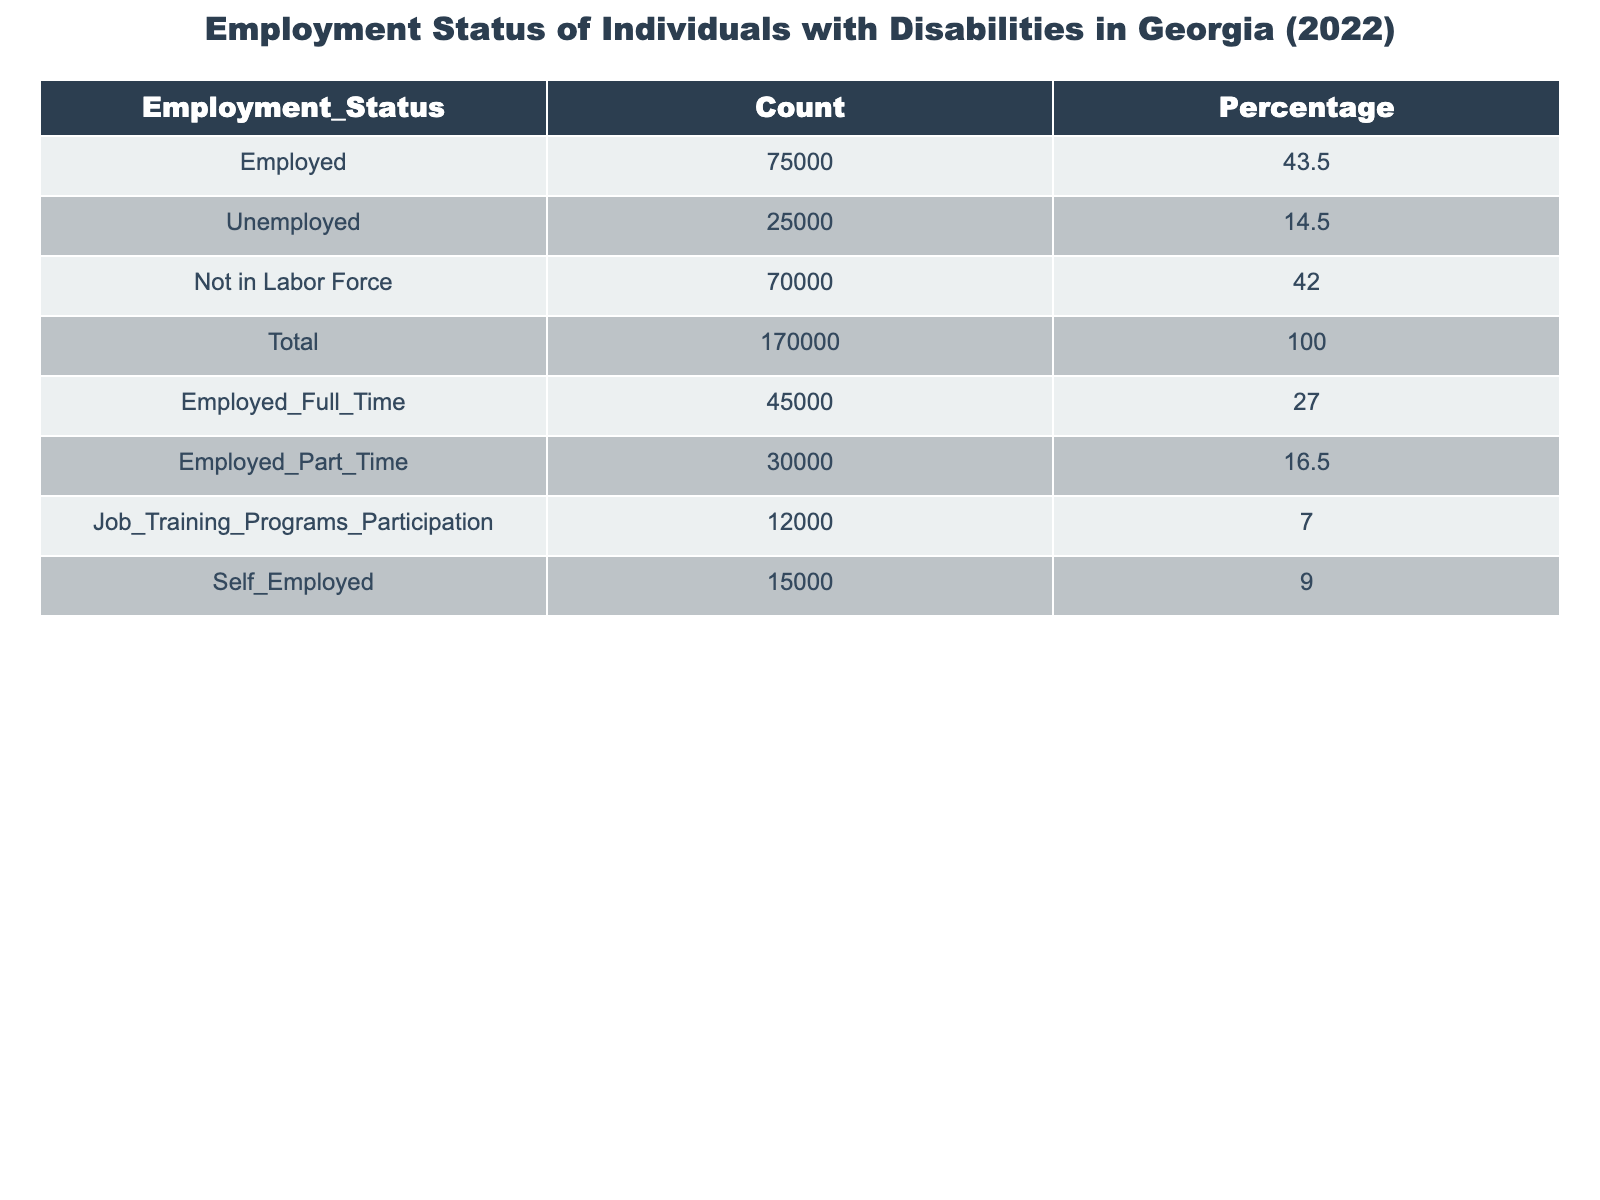What is the total number of individuals with disabilities in Georgia in 2022? The total number of individuals with disabilities is provided in the table as 170,000.
Answer: 170,000 What percentage of individuals with disabilities are employed? The table shows that 43.5% of individuals with disabilities are employed.
Answer: 43.5% How many individuals with disabilities were unemployed in Georgia in 2022? The table lists 25,000 individuals with disabilities as unemployed in Georgia for 2022.
Answer: 25,000 What is the difference between the number of employed individuals and those not in the labor force? The number of employed individuals is 75,000, and those not in the labor force is 70,000. The difference is calculated as 75,000 - 70,000 = 5,000.
Answer: 5,000 What percentage of the total individuals is represented by those not in the labor force? The table states that 42.0% of individuals with disabilities are not in the labor force, which is already given in the data.
Answer: 42.0% How many individuals with disabilities are either employed full-time or part-time? The sum of individuals employed full-time (45,000) and part-time (30,000) is calculated as 45,000 + 30,000 = 75,000.
Answer: 75,000 Is the number of individuals participating in job training programs greater than those who are unemployed? The number of individuals in job training programs is 12,000, while the number unemployed is 25,000. Since 12,000 is less than 25,000, the answer is no.
Answer: No What proportion of employed individuals are self-employed? The number of self-employed individuals is 15,000 out of 75,000 employed. The proportion is calculated by 15,000 / 75,000 = 0.20 or 20%.
Answer: 20% If the unemployed individuals and those not in the labor force combined make up how much of the total individuals? The sum of the unemployed (25,000) and those not in labor force (70,000) is 25,000 + 70,000 = 95,000. This is 95,000 out of 170,000, which is approximately 55.88%.
Answer: 55.88% What is the average number of individuals employed full-time and part-time? The total number of individuals employed (75,000) is divided by the two categories (full-time and part-time), so 75,000 / 2 = 37,500, which is the average.
Answer: 37,500 